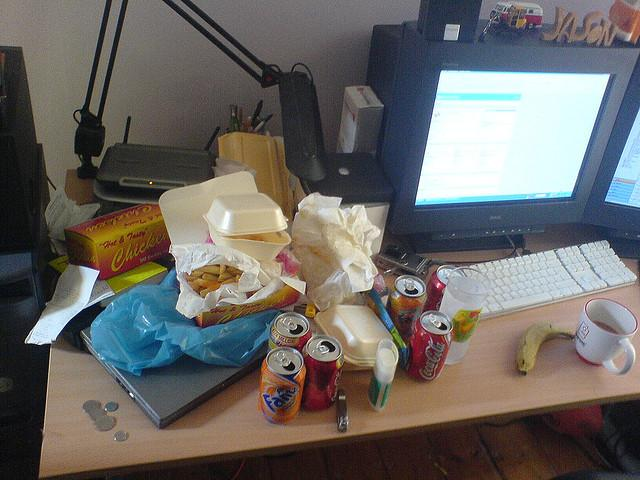Where is Coca-Cola's headquarters located? Please explain your reasoning. georgia. Information can be found online but in a georgia 